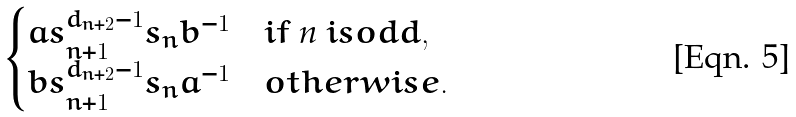<formula> <loc_0><loc_0><loc_500><loc_500>\begin{cases} a s _ { n + 1 } ^ { d _ { n + 2 } - 1 } s _ { n } b ^ { - 1 } & i f $ n $ i s o d d , \\ b s _ { n + 1 } ^ { d _ { n + 2 } - 1 } s _ { n } a ^ { - 1 } & o t h e r w i s e . \end{cases}</formula> 